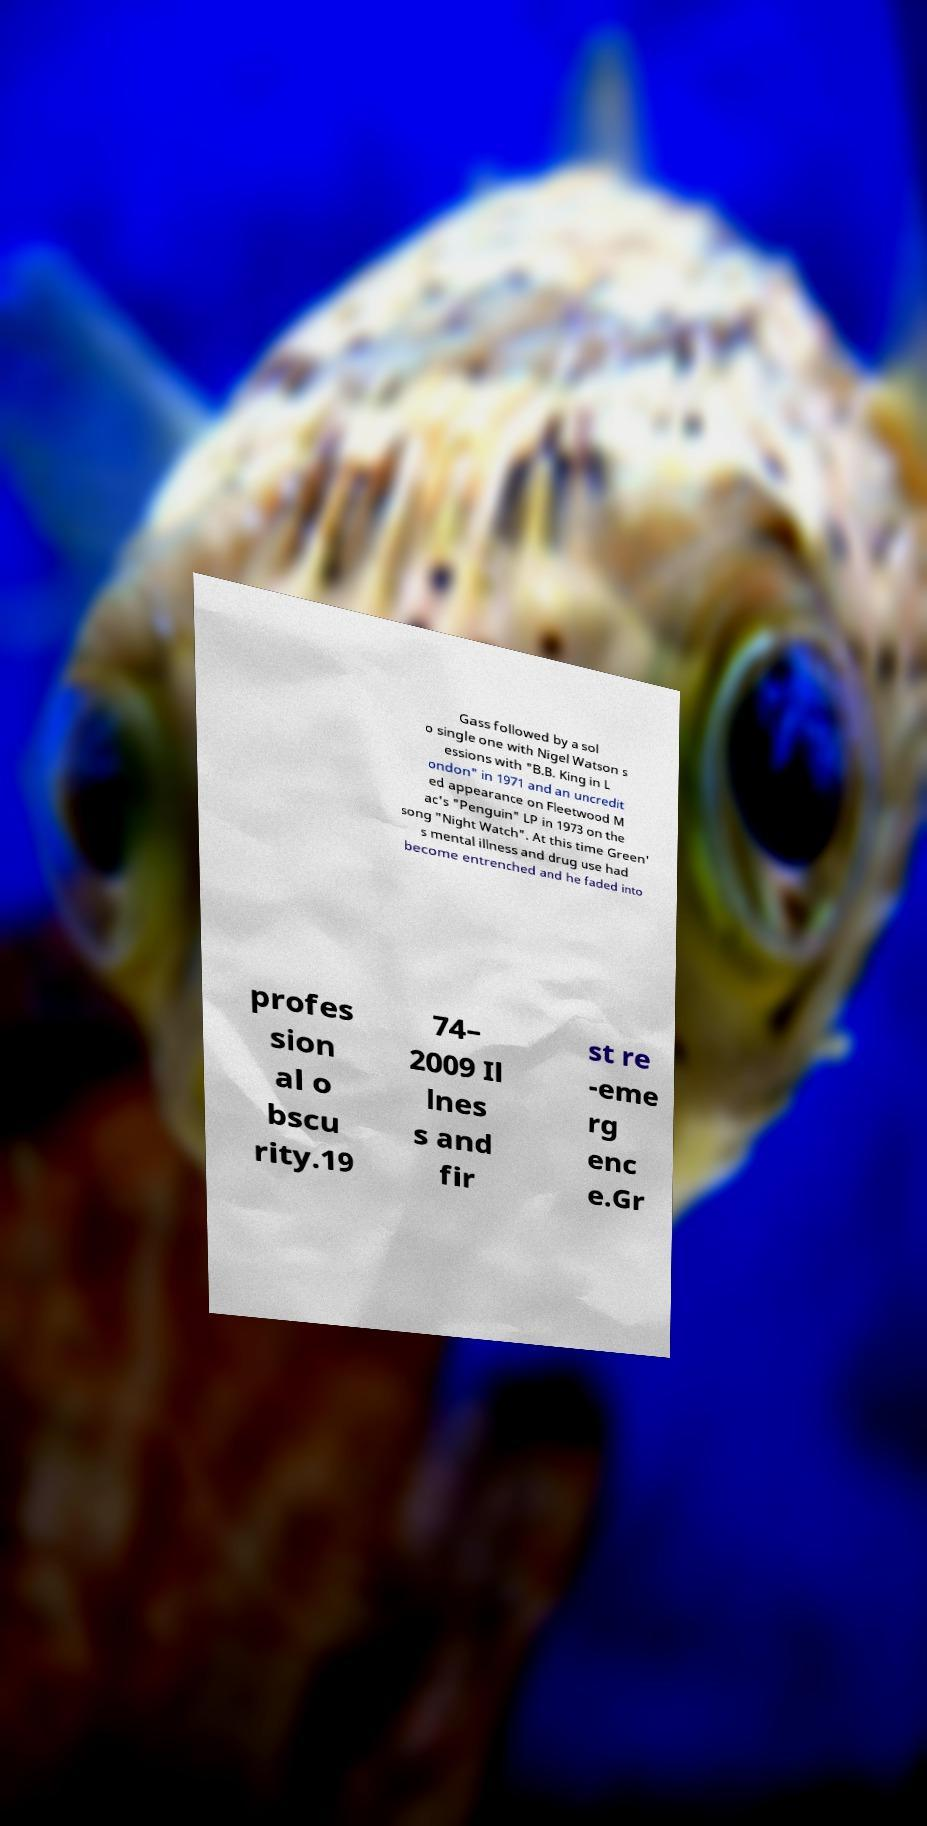There's text embedded in this image that I need extracted. Can you transcribe it verbatim? Gass followed by a sol o single one with Nigel Watson s essions with "B.B. King in L ondon" in 1971 and an uncredit ed appearance on Fleetwood M ac's "Penguin" LP in 1973 on the song "Night Watch". At this time Green' s mental illness and drug use had become entrenched and he faded into profes sion al o bscu rity.19 74– 2009 Il lnes s and fir st re -eme rg enc e.Gr 